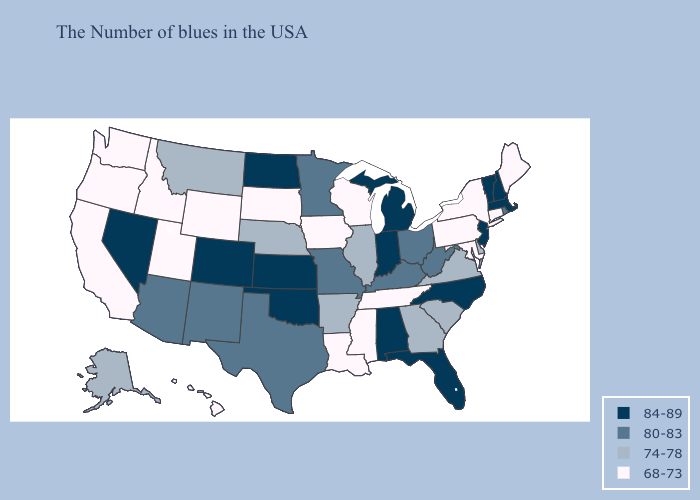What is the lowest value in the Northeast?
Concise answer only. 68-73. What is the value of Wisconsin?
Give a very brief answer. 68-73. What is the lowest value in states that border Alabama?
Short answer required. 68-73. Name the states that have a value in the range 74-78?
Quick response, please. Delaware, Virginia, South Carolina, Georgia, Illinois, Arkansas, Nebraska, Montana, Alaska. Which states have the lowest value in the USA?
Answer briefly. Maine, Connecticut, New York, Maryland, Pennsylvania, Tennessee, Wisconsin, Mississippi, Louisiana, Iowa, South Dakota, Wyoming, Utah, Idaho, California, Washington, Oregon, Hawaii. Name the states that have a value in the range 74-78?
Concise answer only. Delaware, Virginia, South Carolina, Georgia, Illinois, Arkansas, Nebraska, Montana, Alaska. What is the value of Arkansas?
Answer briefly. 74-78. Among the states that border New Jersey , which have the highest value?
Answer briefly. Delaware. Does Nevada have the highest value in the West?
Give a very brief answer. Yes. Among the states that border West Virginia , which have the lowest value?
Quick response, please. Maryland, Pennsylvania. What is the value of New Mexico?
Concise answer only. 80-83. What is the value of Nevada?
Give a very brief answer. 84-89. What is the value of Nebraska?
Be succinct. 74-78. What is the value of Florida?
Keep it brief. 84-89. 